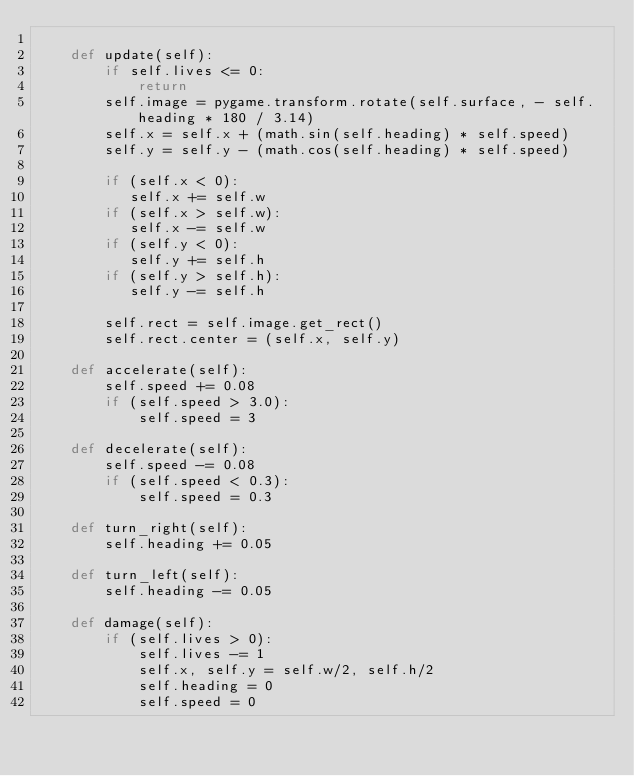<code> <loc_0><loc_0><loc_500><loc_500><_Python_>
    def update(self):
        if self.lives <= 0:
            return
        self.image = pygame.transform.rotate(self.surface, - self.heading * 180 / 3.14)
        self.x = self.x + (math.sin(self.heading) * self.speed)
        self.y = self.y - (math.cos(self.heading) * self.speed)

        if (self.x < 0):
           self.x += self.w
        if (self.x > self.w):
           self.x -= self.w
        if (self.y < 0):
           self.y += self.h
        if (self.y > self.h):
           self.y -= self.h

        self.rect = self.image.get_rect()
        self.rect.center = (self.x, self.y)

    def accelerate(self):
        self.speed += 0.08
        if (self.speed > 3.0):
            self.speed = 3

    def decelerate(self):
        self.speed -= 0.08
        if (self.speed < 0.3):
            self.speed = 0.3

    def turn_right(self):
        self.heading += 0.05

    def turn_left(self):
        self.heading -= 0.05

    def damage(self):
        if (self.lives > 0):
            self.lives -= 1
            self.x, self.y = self.w/2, self.h/2
            self.heading = 0
            self.speed = 0
</code> 